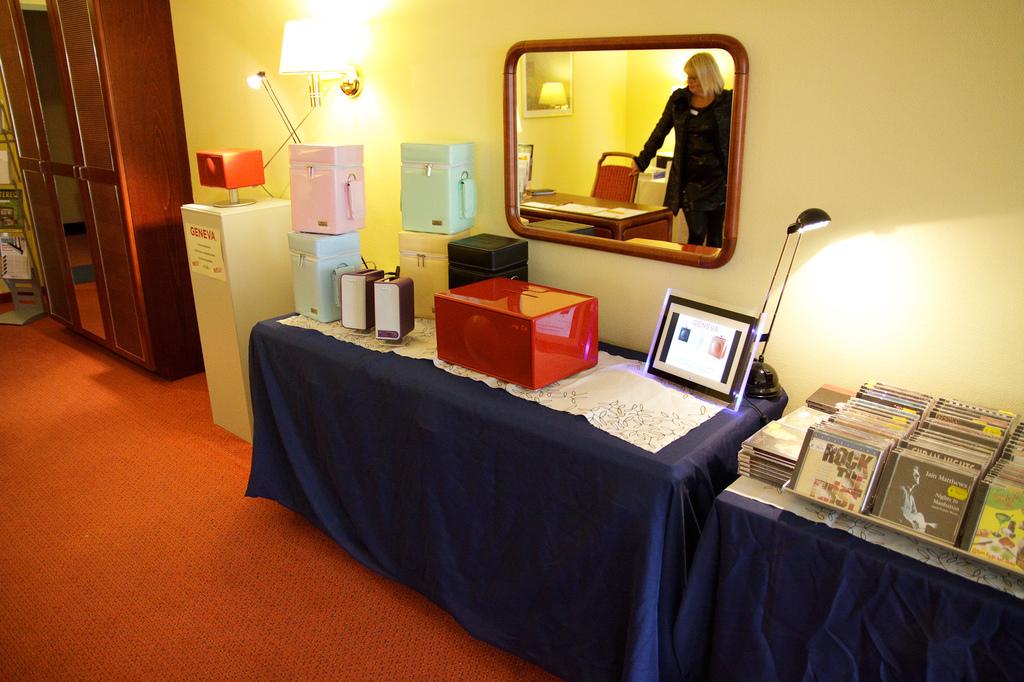What is the album name in the left corner?
Your response must be concise. Rock the first. 